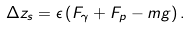<formula> <loc_0><loc_0><loc_500><loc_500>\Delta z _ { s } = \epsilon \left ( F _ { \gamma } + F _ { p } - m g \right ) .</formula> 